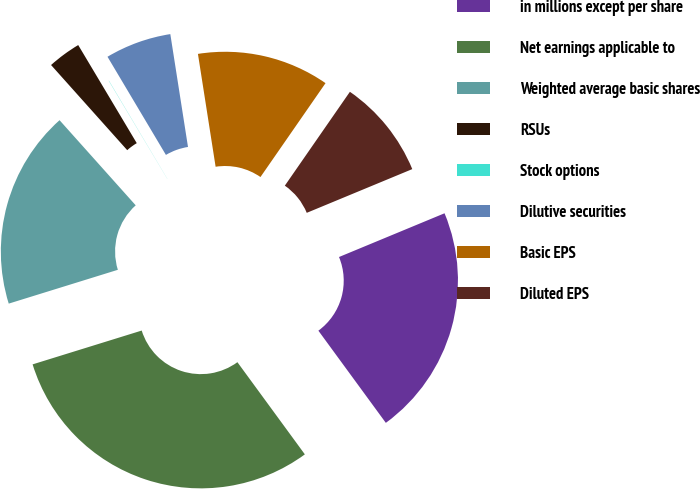Convert chart. <chart><loc_0><loc_0><loc_500><loc_500><pie_chart><fcel>in millions except per share<fcel>Net earnings applicable to<fcel>Weighted average basic shares<fcel>RSUs<fcel>Stock options<fcel>Dilutive securities<fcel>Basic EPS<fcel>Diluted EPS<nl><fcel>21.2%<fcel>30.27%<fcel>18.17%<fcel>3.05%<fcel>0.02%<fcel>6.07%<fcel>12.12%<fcel>9.1%<nl></chart> 